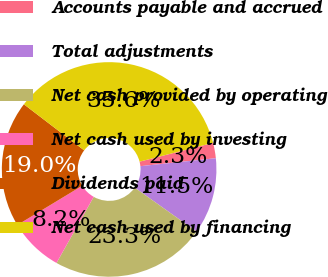Convert chart to OTSL. <chart><loc_0><loc_0><loc_500><loc_500><pie_chart><fcel>Accounts payable and accrued<fcel>Total adjustments<fcel>Net cash provided by operating<fcel>Net cash used by investing<fcel>Dividends paid<fcel>Net cash used by financing<nl><fcel>2.32%<fcel>11.51%<fcel>23.32%<fcel>8.18%<fcel>19.05%<fcel>35.62%<nl></chart> 